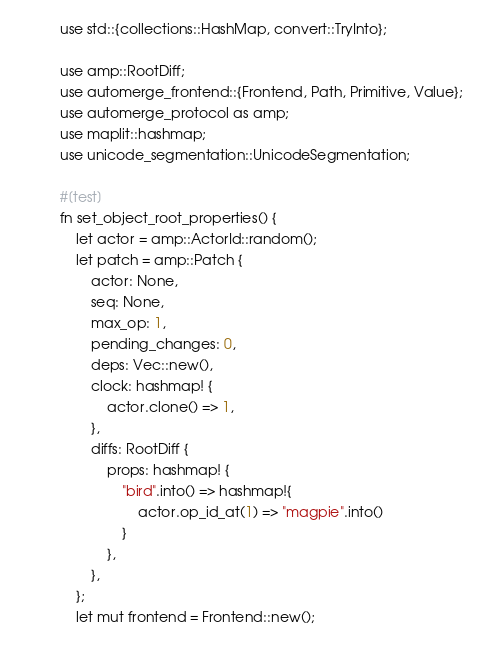Convert code to text. <code><loc_0><loc_0><loc_500><loc_500><_Rust_>use std::{collections::HashMap, convert::TryInto};

use amp::RootDiff;
use automerge_frontend::{Frontend, Path, Primitive, Value};
use automerge_protocol as amp;
use maplit::hashmap;
use unicode_segmentation::UnicodeSegmentation;

#[test]
fn set_object_root_properties() {
    let actor = amp::ActorId::random();
    let patch = amp::Patch {
        actor: None,
        seq: None,
        max_op: 1,
        pending_changes: 0,
        deps: Vec::new(),
        clock: hashmap! {
            actor.clone() => 1,
        },
        diffs: RootDiff {
            props: hashmap! {
                "bird".into() => hashmap!{
                    actor.op_id_at(1) => "magpie".into()
                }
            },
        },
    };
    let mut frontend = Frontend::new();</code> 